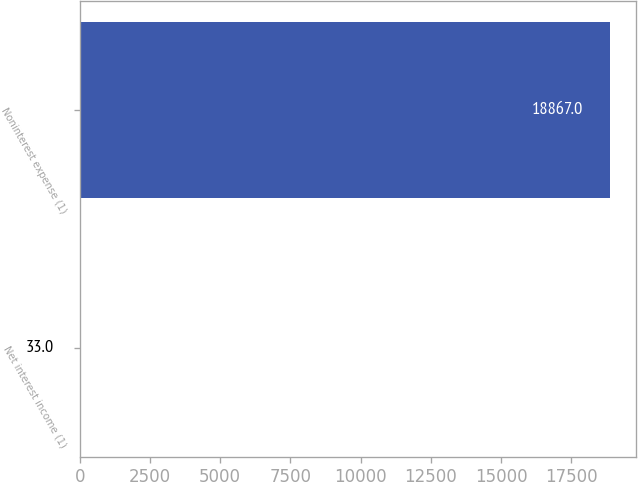Convert chart. <chart><loc_0><loc_0><loc_500><loc_500><bar_chart><fcel>Net interest income (1)<fcel>Noninterest expense (1)<nl><fcel>33<fcel>18867<nl></chart> 